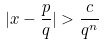<formula> <loc_0><loc_0><loc_500><loc_500>| x - \frac { p } { q } | > \frac { c } { q ^ { n } }</formula> 